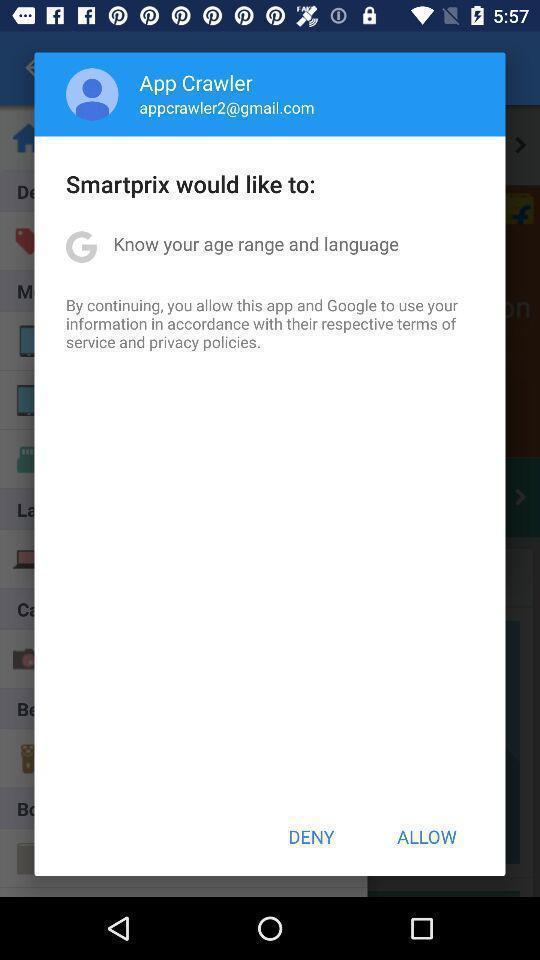Give me a summary of this screen capture. Pop-up showing continuation page. 